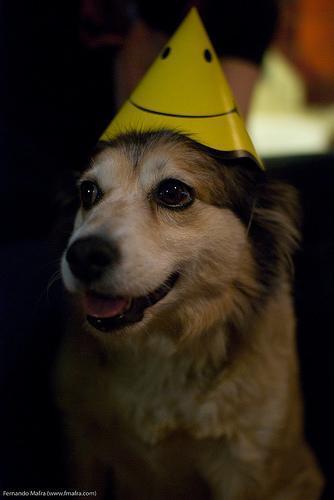How many dogs are there?
Give a very brief answer. 1. 